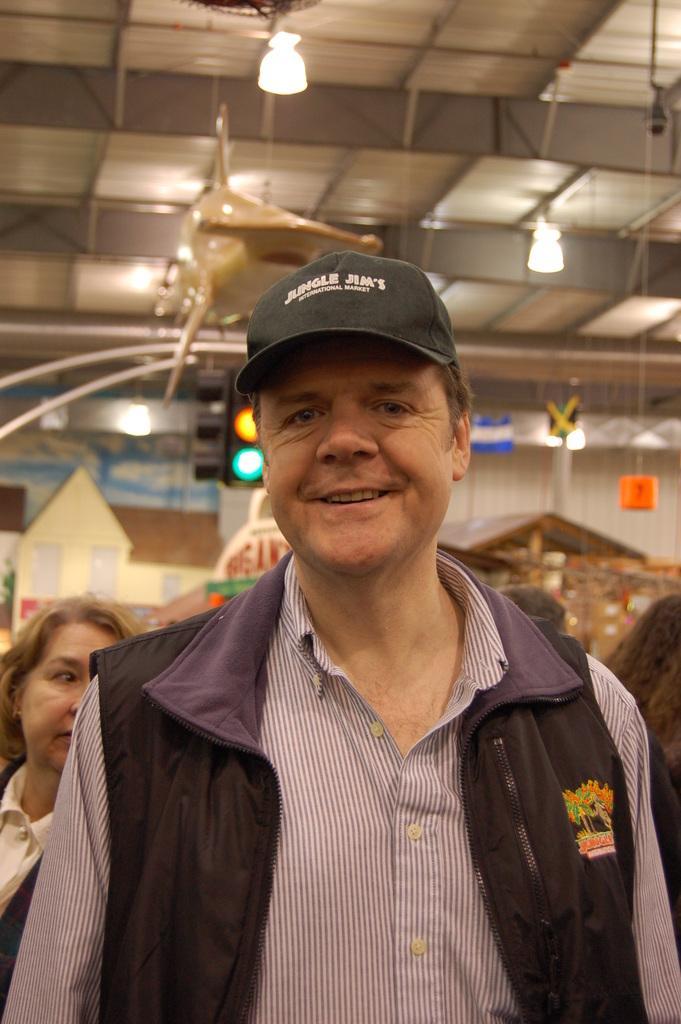Can you describe this image briefly? In the center of the image we can see a man standing, smiling and wearing a black cap. In the background we can also see a woman. Image also consists of ceiling lights and some lights and we can also see the roof for shelter. 